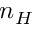<formula> <loc_0><loc_0><loc_500><loc_500>n _ { H }</formula> 